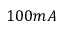Convert formula to latex. <formula><loc_0><loc_0><loc_500><loc_500>1 0 0 m A</formula> 